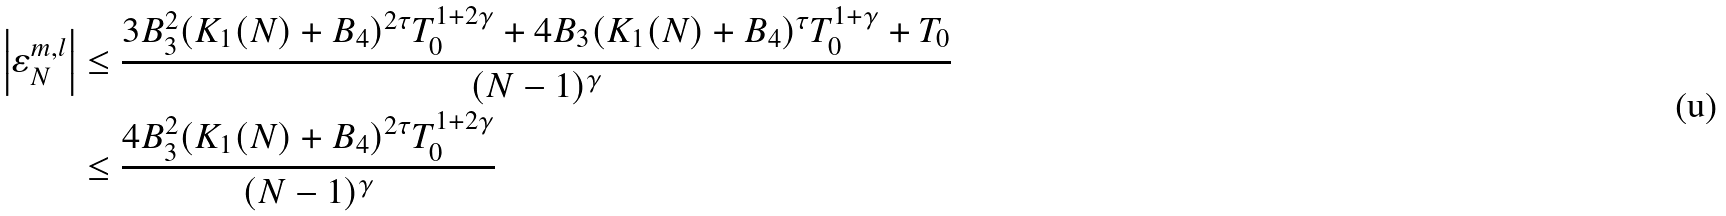Convert formula to latex. <formula><loc_0><loc_0><loc_500><loc_500>\left | \varepsilon _ { N } ^ { m , l } \right | & \leq \frac { 3 B _ { 3 } ^ { 2 } ( K _ { 1 } ( N ) + B _ { 4 } ) ^ { 2 \tau } T _ { 0 } ^ { 1 + 2 \gamma } + 4 B _ { 3 } ( K _ { 1 } ( N ) + B _ { 4 } ) ^ { \tau } T _ { 0 } ^ { 1 + \gamma } + T _ { 0 } } { ( N - 1 ) ^ { \gamma } } \\ & \leq \frac { 4 B _ { 3 } ^ { 2 } ( K _ { 1 } ( N ) + B _ { 4 } ) ^ { 2 \tau } T _ { 0 } ^ { 1 + 2 \gamma } } { ( N - 1 ) ^ { \gamma } }</formula> 